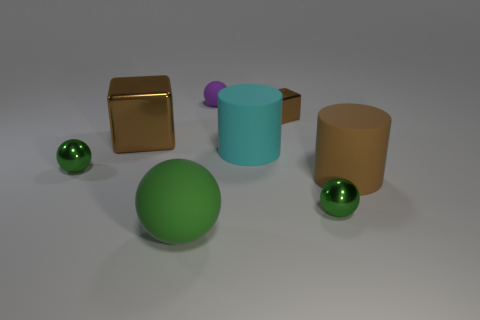Does the matte sphere right of the green rubber thing have the same size as the metal cube to the right of the large brown metallic thing? Upon examining the image, the matte sphere located to the right of the green cylindrical object appears to have a very similar size when compared to the metal cube positioned adjacent to the larger brown cylinder. However, without precise measurements, it cannot be confirmed if they are identical in size, but visually they seem to be close in dimension. 